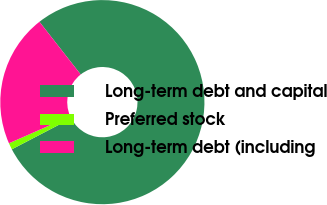Convert chart. <chart><loc_0><loc_0><loc_500><loc_500><pie_chart><fcel>Long-term debt and capital<fcel>Preferred stock<fcel>Long-term debt (including<nl><fcel>77.93%<fcel>1.04%<fcel>21.03%<nl></chart> 